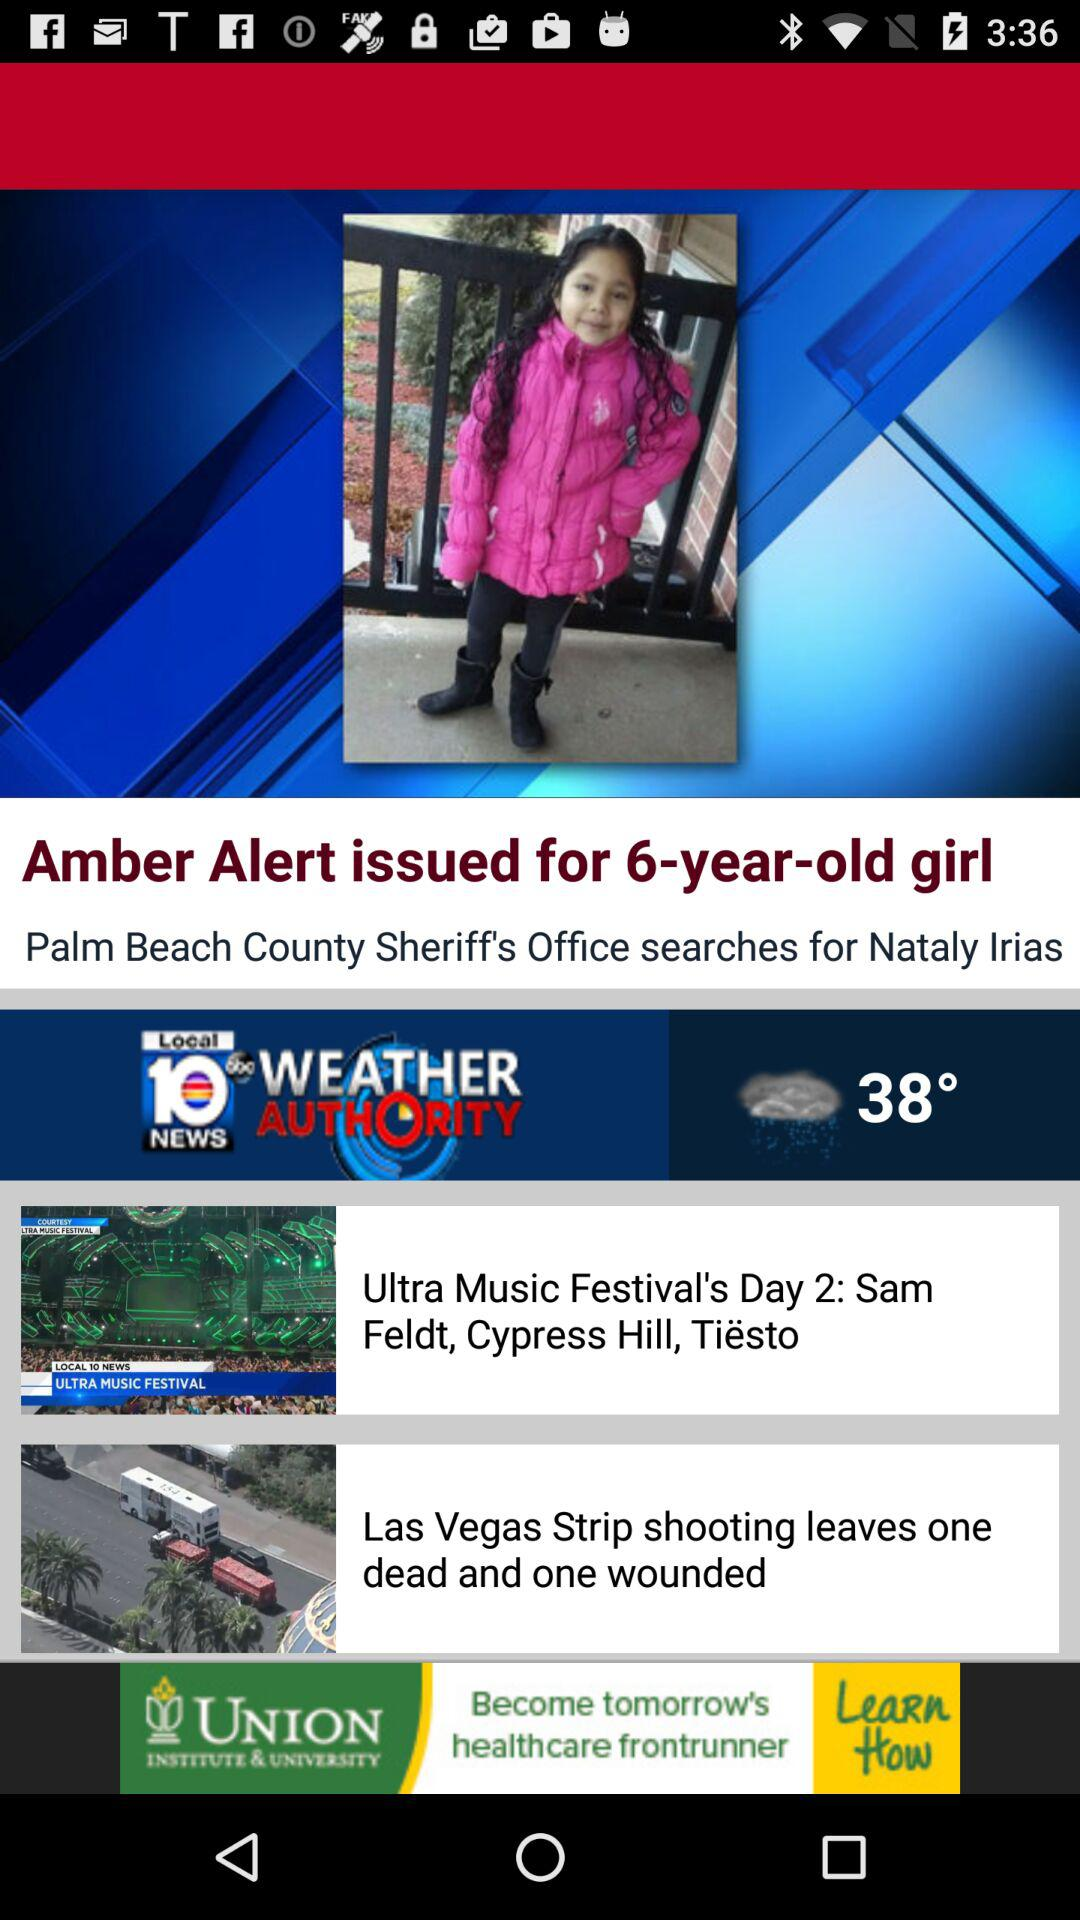What's the girl's name? The girl's name is Nataly Irias. 